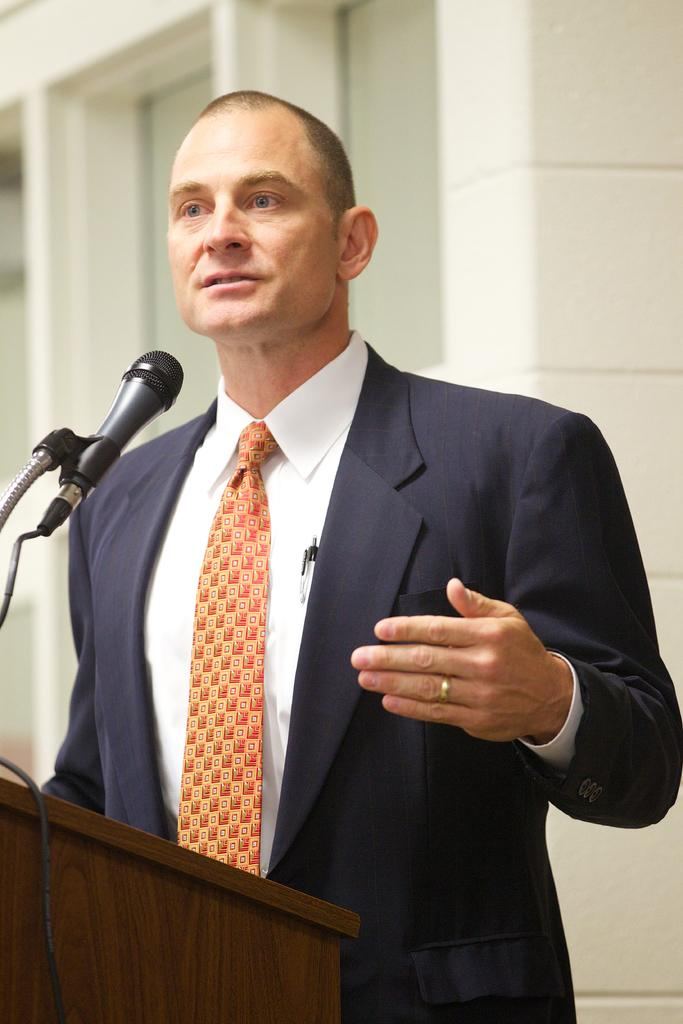Who is the main subject in the image? There is a man in the image. What is the man wearing in the image? The man is wearing a blazer and a tie in the image. What is the man doing in the image? The man is standing at a podium and talking on a microphone in the image. What position does the man sleep in during the speech in the image? The image does not show the man sleeping; he is actively talking on a microphone while standing at a podium. 